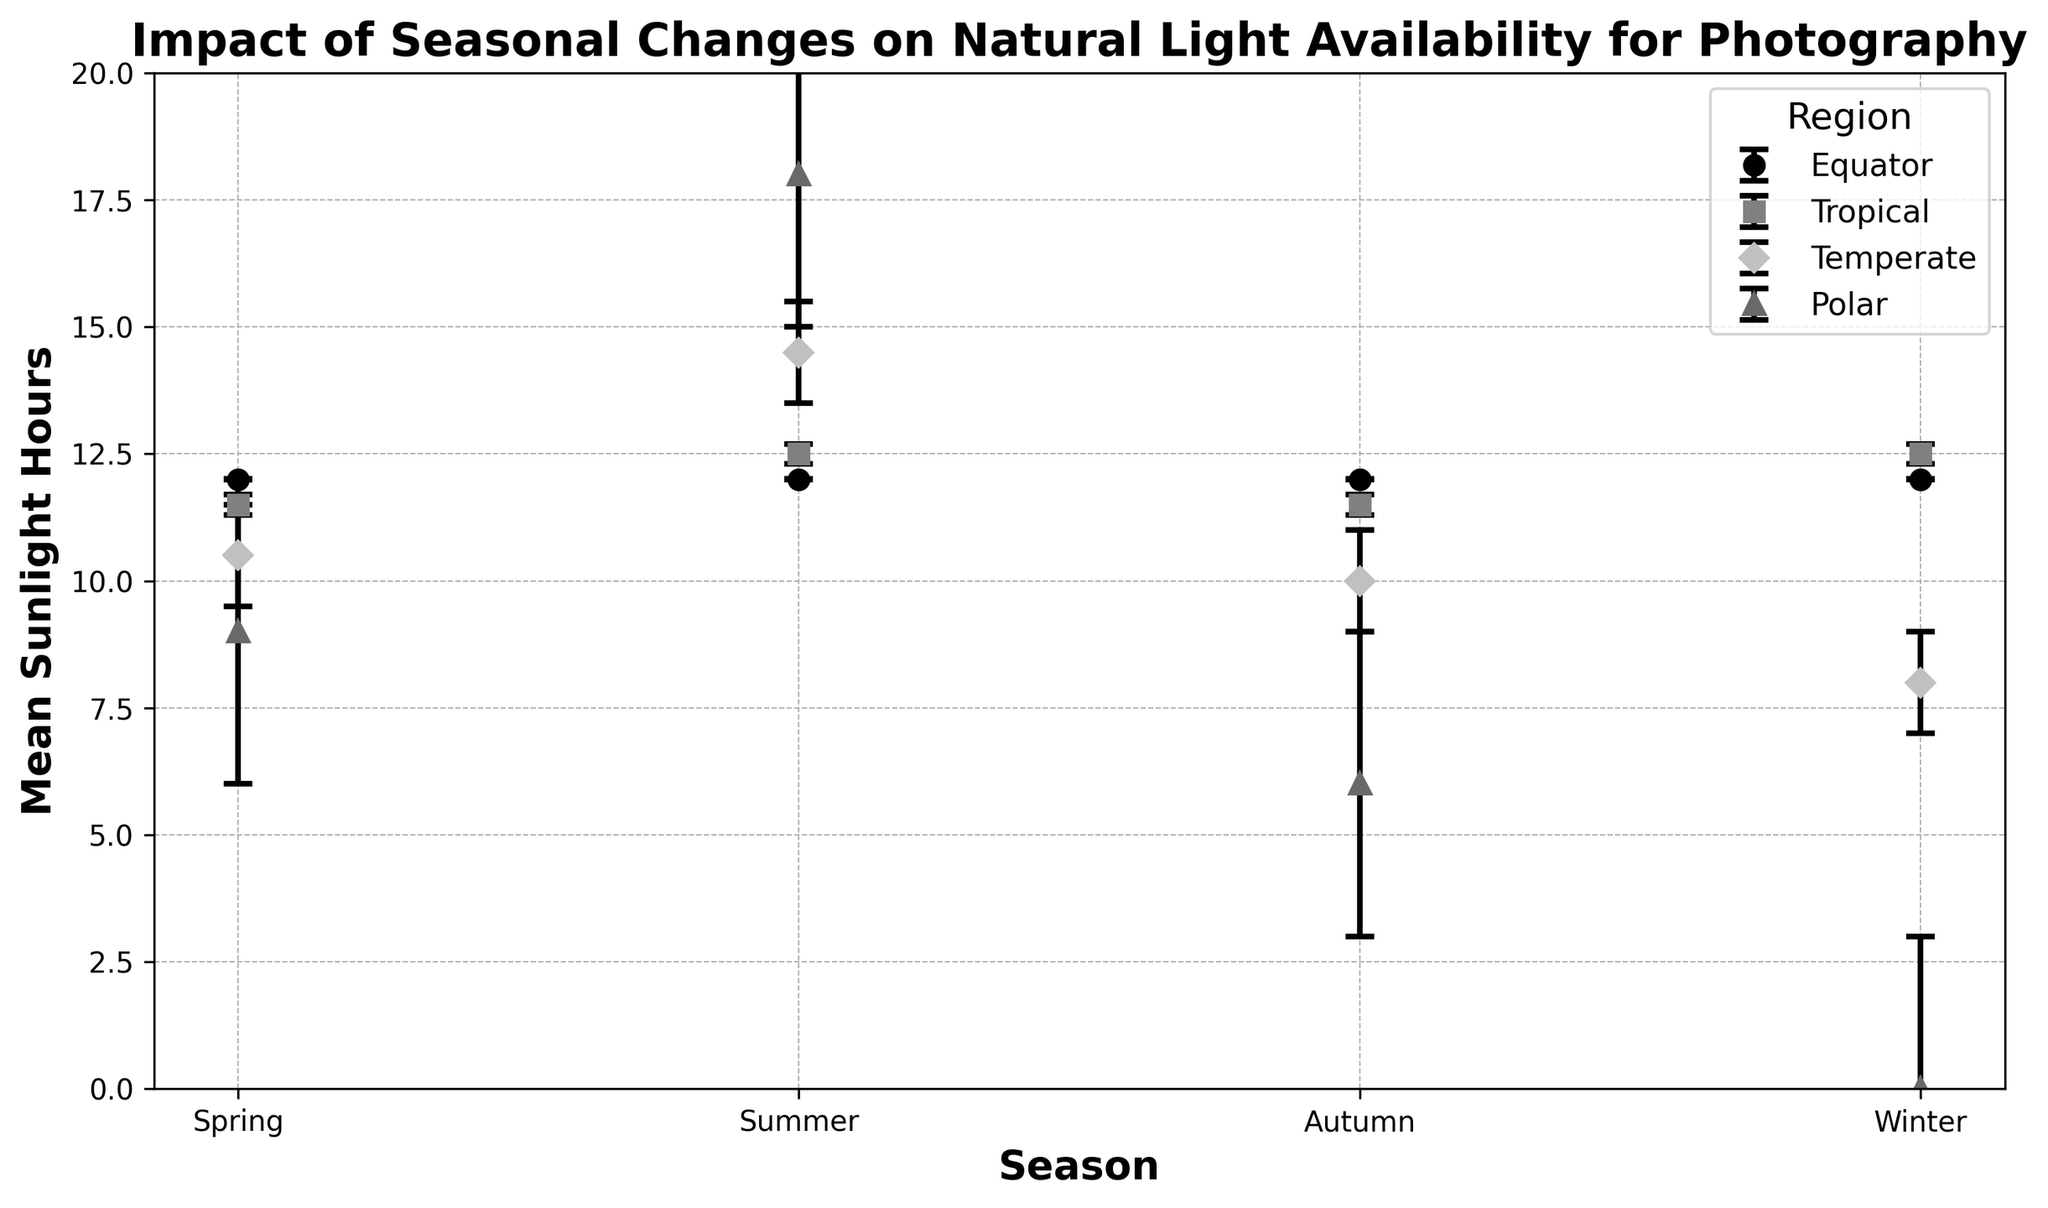Which region shows the least amount of seasonal variation in sunlight hours? The region at the equator shows the least variation; the error bars (indicating standard deviation) are very small (0.01) and the mean sunlight hours remain consistently at 12 hours across all seasons.
Answer: Equator In which season does the Polar region experience the maximum sunlight hours, and what are these hours? By examining the plot, the Polar region reaches its maximum sunlight hours in the summer, shown by an error bar extending to the highest point, approximately 18 hours.
Answer: Summer, 18 hours How does the standard deviation of sunlight hours in the Polar region during winter compare to the mean hours in the Temperate region during spring? The standard deviation for the Polar region in winter is 3 hours, and the mean sunlight hours in the Temperate region during spring is 10.50 hours. Comparing these shows that the standard deviation is less than the mean sunlight duration.
Answer: The standard deviation in the Polar region in winter (3 hours) is less than the mean in the Temperate region in spring (10.50 hours) Which season sees the highest variation (greatest standard deviation) in sunlight hours across all regions? By examining the length of the error bars, the Bar/ might indicate greater variation. Notice the error bars are used to visualize the standard deviation values. The Polar region in winter shows the longest error bar of 3 hours.
Answer: Winter Between the Temperate region in summer and the Tropical region in summer, which has a higher mean sunlight hours and by how much? From the figure, the Temperate region in summer has a mean sunlight duration of 14.50 hours, while the Tropical region in summer has a mean of 12.50 hours. The difference is 14.50 - 12.50 = 2 hours.
Answer: Temperate region, by 2 hours What is the average mean sunlight hours across all seasons for the Tropical region? The mean sunlight hours for the Tropical region are as follows: 11.50 (Spring), 12.50 (Summer), 11.50 (Autumn), and 12.50 (Winter). The average is (11.50 + 12.50 + 11.50 + 12.50) / 4 = 12 hours.
Answer: 12 hours How much do the mean sunlight hours in the Polar region differ from winter to summer? The mean sunlight hours in the Polar region during winter is 0 and during summer it is 18. The difference is 18 - 0 = 18 hours.
Answer: 18 hours Which region has the most consistent mean sunlight hours throughout the seasons, and what is the standard deviation for this region? The Equator region has the most consistent mean sunlight across all seasons with 12 hours, and the standard deviation is 0.01 hours.
Answer: Equator, 0.01 In the Temperate region, which season has the lowest mean sunlight hours and what is its value? In the Temperate region, winter has the lowest mean sunlight hours, represented by the shortest error bar length in this region, indicating 8 hours.
Answer: Winter, 8 hours 